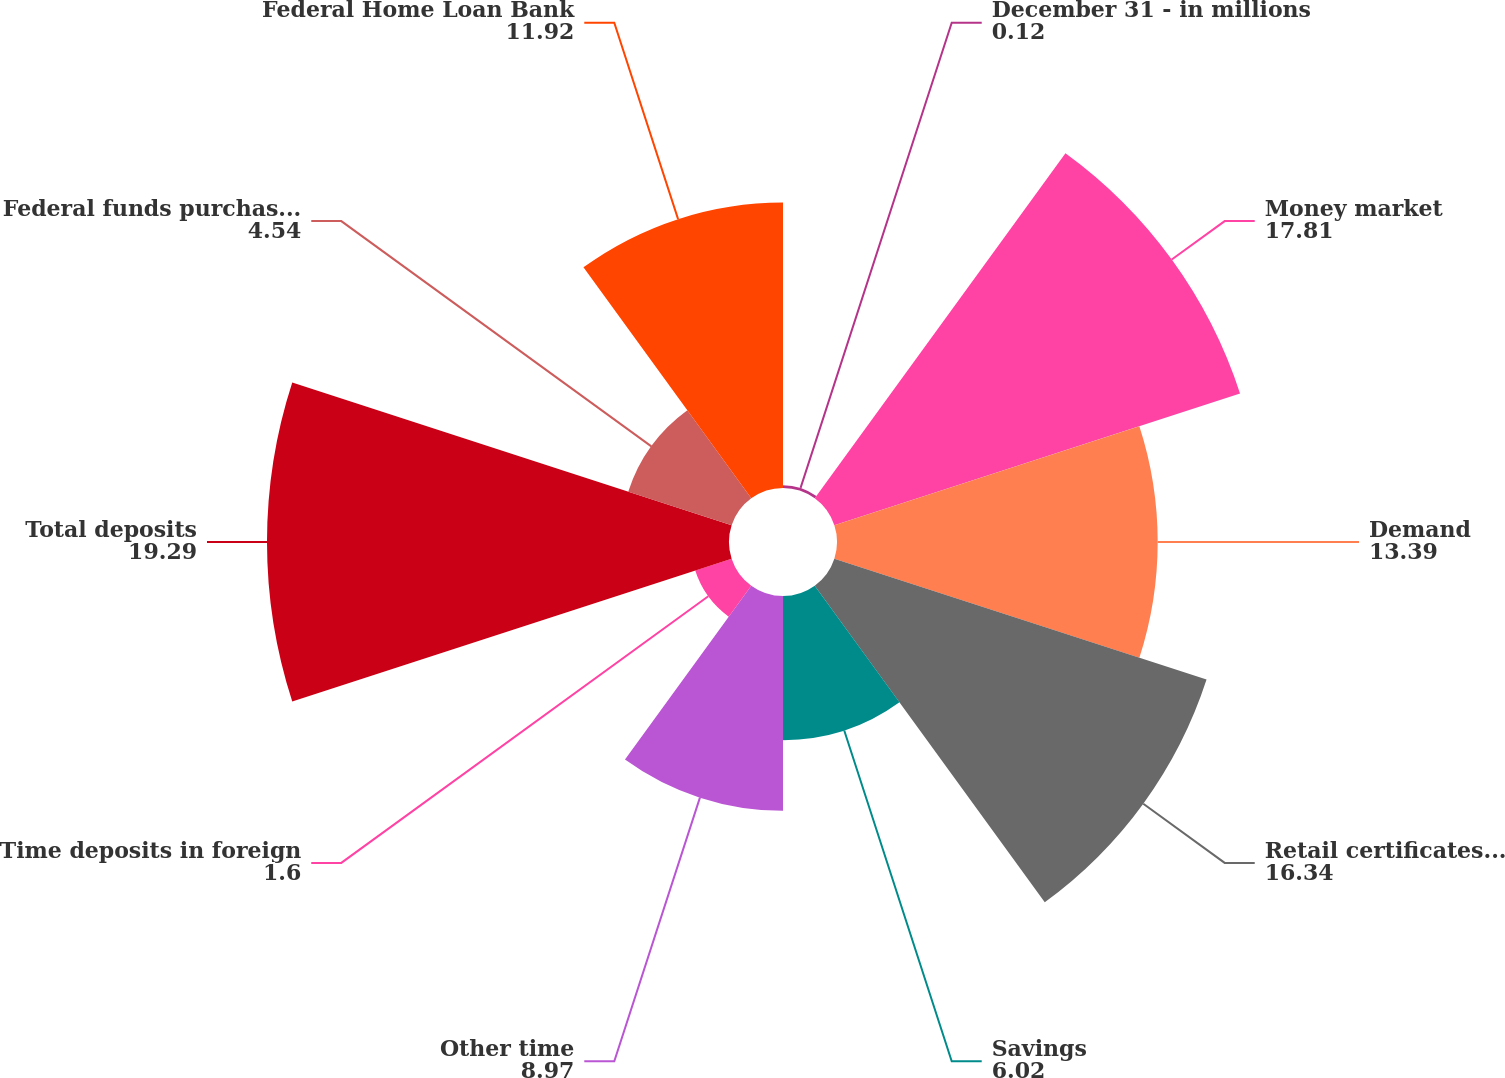Convert chart to OTSL. <chart><loc_0><loc_0><loc_500><loc_500><pie_chart><fcel>December 31 - in millions<fcel>Money market<fcel>Demand<fcel>Retail certificates of deposit<fcel>Savings<fcel>Other time<fcel>Time deposits in foreign<fcel>Total deposits<fcel>Federal funds purchased and<fcel>Federal Home Loan Bank<nl><fcel>0.12%<fcel>17.81%<fcel>13.39%<fcel>16.34%<fcel>6.02%<fcel>8.97%<fcel>1.6%<fcel>19.29%<fcel>4.54%<fcel>11.92%<nl></chart> 